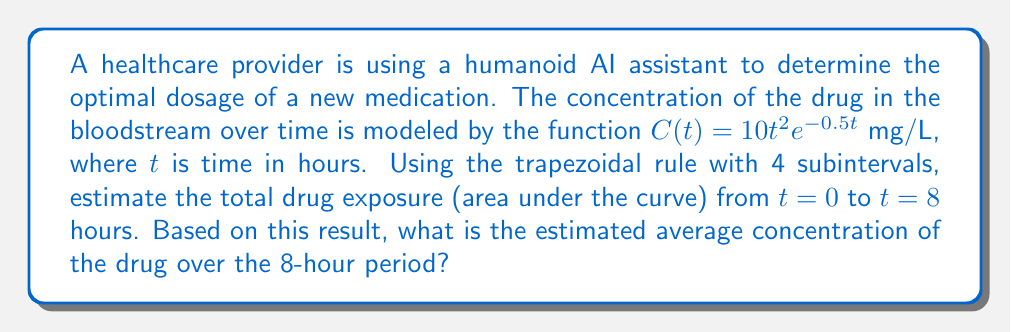Can you answer this question? 1) The trapezoidal rule for numerical integration is given by:

   $$\int_a^b f(x)dx \approx \frac{h}{2}[f(x_0) + 2f(x_1) + 2f(x_2) + ... + 2f(x_{n-1}) + f(x_n)]$$

   where $h = \frac{b-a}{n}$, and $n$ is the number of subintervals.

2) In this case, $a=0$, $b=8$, and $n=4$. So, $h = \frac{8-0}{4} = 2$.

3) We need to evaluate $C(t)$ at $t = 0, 2, 4, 6,$ and $8$:

   $C(0) = 10(0)^2e^{-0.5(0)} = 0$
   $C(2) = 10(2)^2e^{-0.5(2)} = 40e^{-1} \approx 14.7152$
   $C(4) = 10(4)^2e^{-0.5(4)} = 160e^{-2} \approx 21.6292$
   $C(6) = 10(6)^2e^{-0.5(6)} = 360e^{-3} \approx 17.8477$
   $C(8) = 10(8)^2e^{-0.5(8)} = 640e^{-4} \approx 11.6898$

4) Applying the trapezoidal rule:

   $$\text{AUC} \approx \frac{2}{2}[0 + 2(14.7152) + 2(21.6292) + 2(17.8477) + 11.6898]$$
   $$= 1[0 + 29.4304 + 43.2584 + 35.6954 + 11.6898]$$
   $$= 120.0740 \text{ mg⋅h/L}$$

5) To find the average concentration, divide the AUC by the time period:

   $$\text{Average Concentration} = \frac{\text{AUC}}{\text{Time Period}} = \frac{120.0740}{8} = 15.0093 \text{ mg/L}$$
Answer: 15.0093 mg/L 